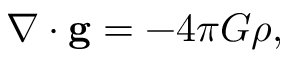<formula> <loc_0><loc_0><loc_500><loc_500>\nabla \cdot g = - 4 \pi G \rho ,</formula> 